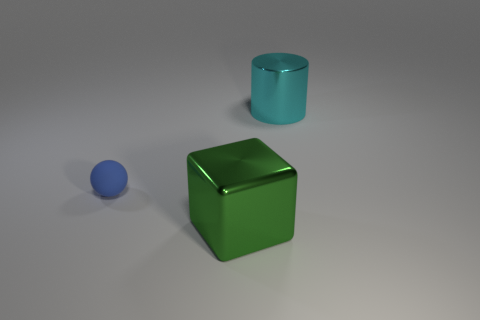How many things are big green cubes or tiny blue shiny objects?
Your answer should be very brief. 1. Are there any big metal objects?
Offer a very short reply. Yes. There is a shiny object that is to the right of the big thing in front of the blue rubber sphere; what shape is it?
Offer a terse response. Cylinder. How many objects are either big objects that are left of the large cyan cylinder or objects behind the big metal cube?
Offer a terse response. 3. What material is the cyan cylinder that is the same size as the green thing?
Make the answer very short. Metal. What color is the matte thing?
Make the answer very short. Blue. What is the material of the thing that is behind the large metal cube and to the right of the ball?
Offer a very short reply. Metal. Are there any cubes that are in front of the large object that is right of the shiny object in front of the cyan shiny cylinder?
Give a very brief answer. Yes. There is a large cylinder; are there any metallic blocks behind it?
Offer a very short reply. No. What number of other objects are there of the same shape as the green metal object?
Provide a short and direct response. 0. 